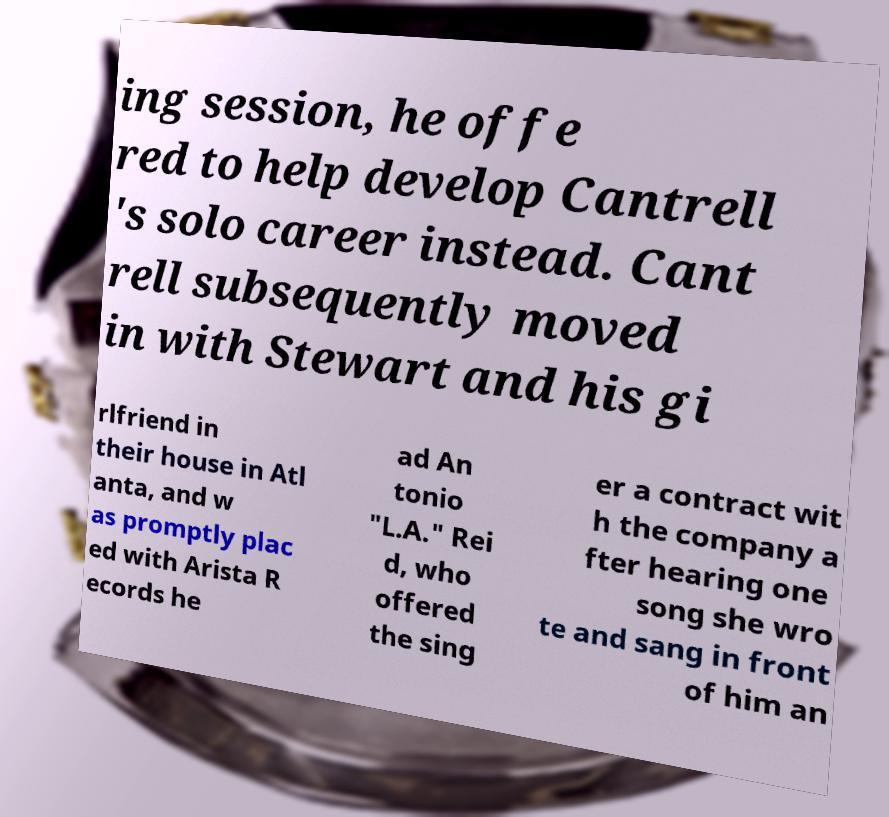Can you accurately transcribe the text from the provided image for me? ing session, he offe red to help develop Cantrell 's solo career instead. Cant rell subsequently moved in with Stewart and his gi rlfriend in their house in Atl anta, and w as promptly plac ed with Arista R ecords he ad An tonio "L.A." Rei d, who offered the sing er a contract wit h the company a fter hearing one song she wro te and sang in front of him an 